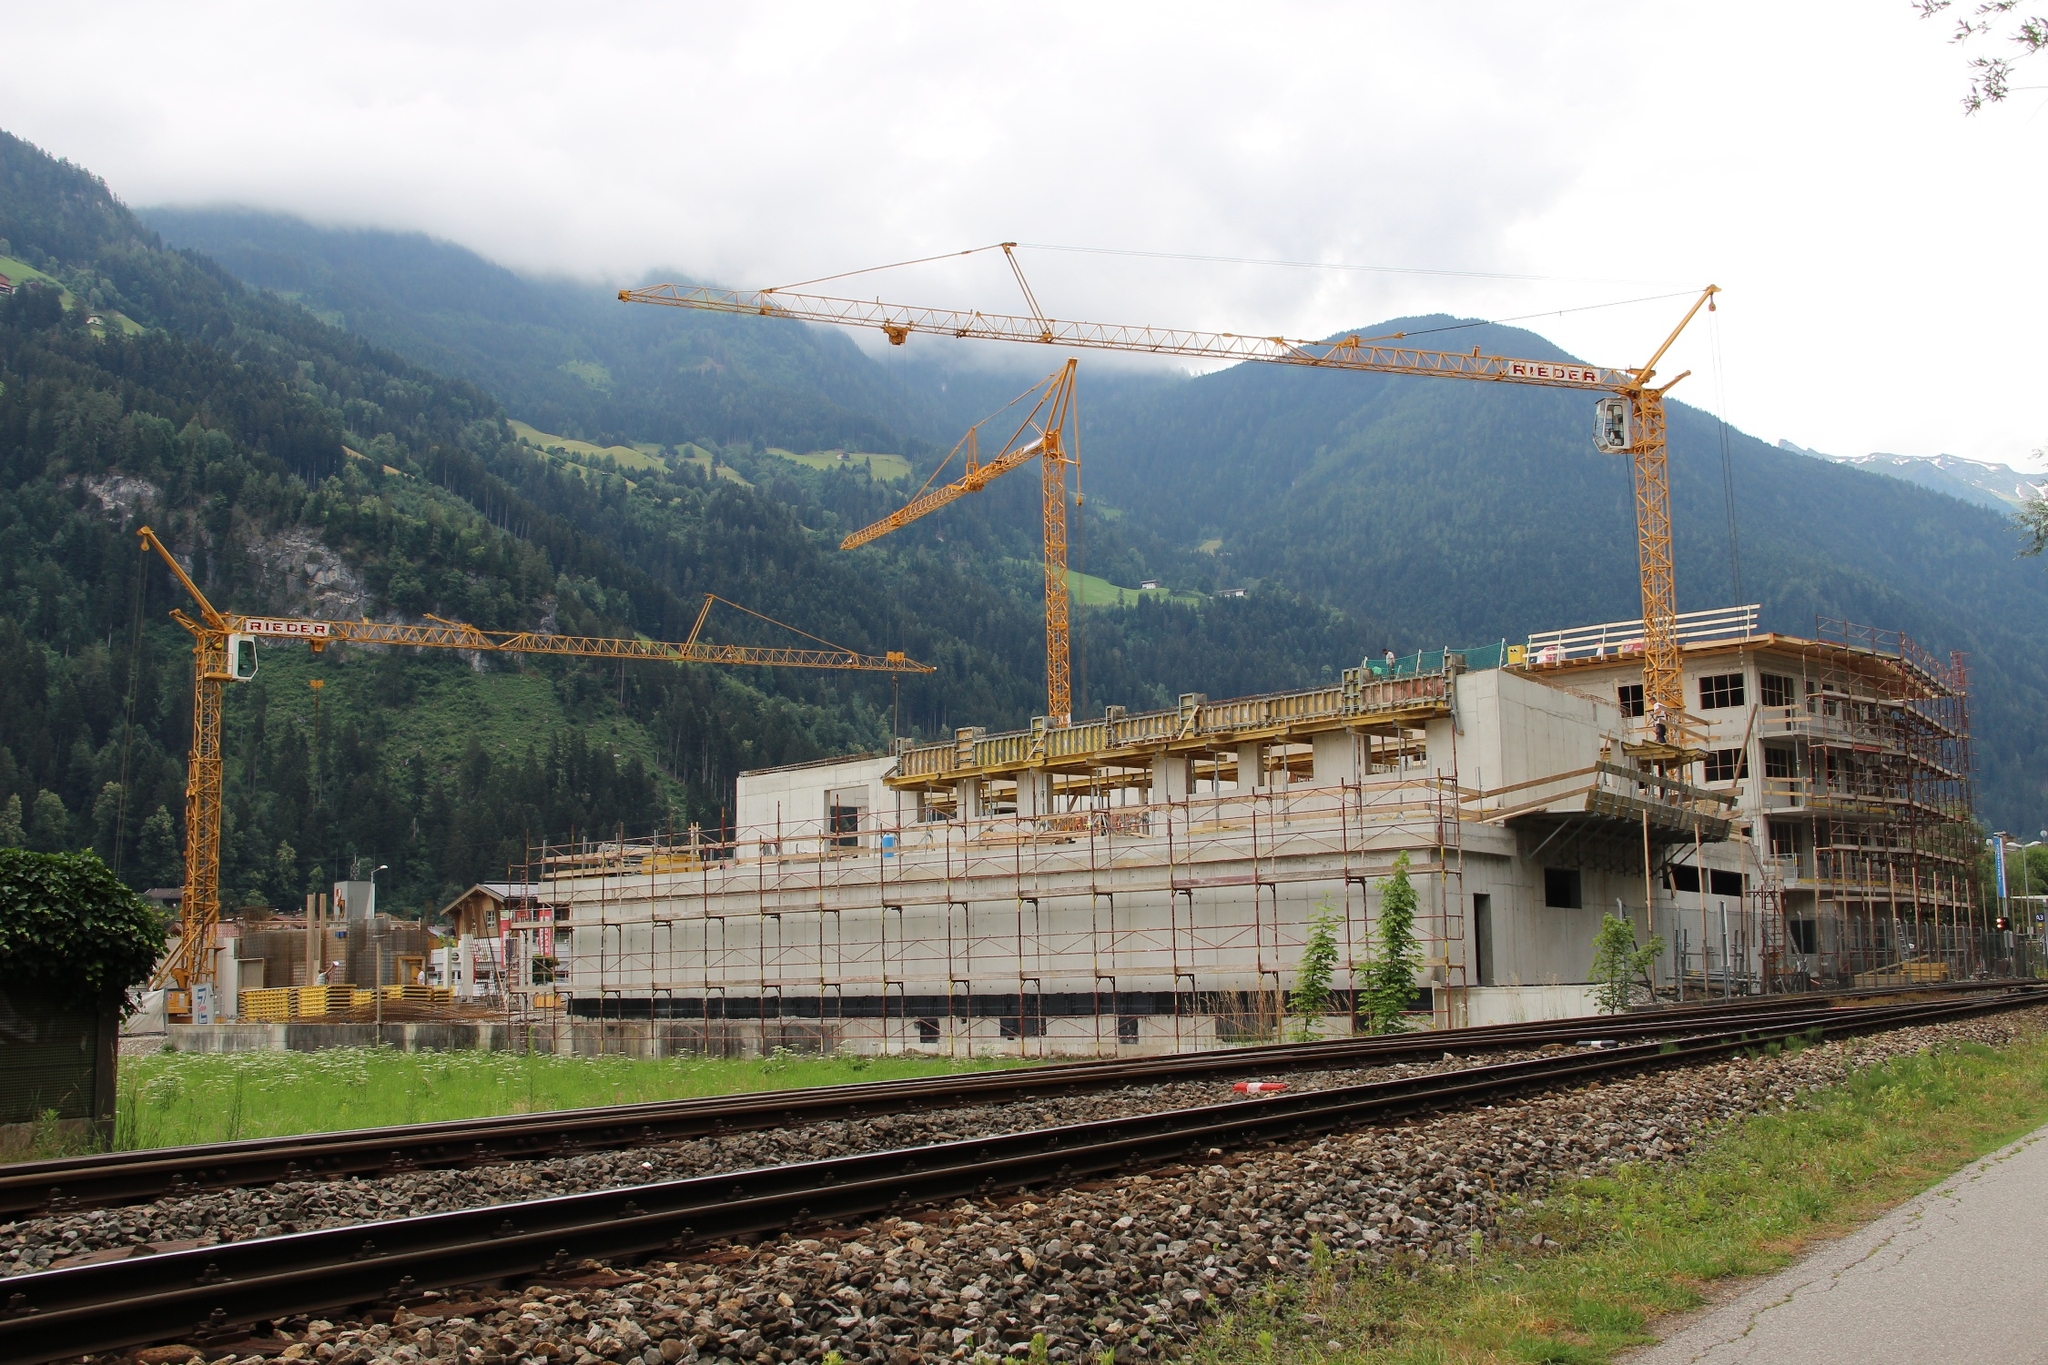If this construction site were part of a fantasy story, what role might it play? In a world where the veil between reality and magic is thin, the construction site could serve as the foundation for a grand citadel that will pierce the heavens. This citadel would be the heart of a new era, a place where ancient spells and modern engineering converge. The cranes, imbued with the power of long-forgotten gods, work tirelessly day and night, guided by rune-covered blueprints. The railways below, once mere transport lines, now whisper secrets from the underworld, guarded by spectral sentinels. The encircling forest holds enchanted creatures that both aid and impede progress, ensuring that only the truly worthy can complete the edifice destined to become a nexus of unparalleled power and intrigue. 